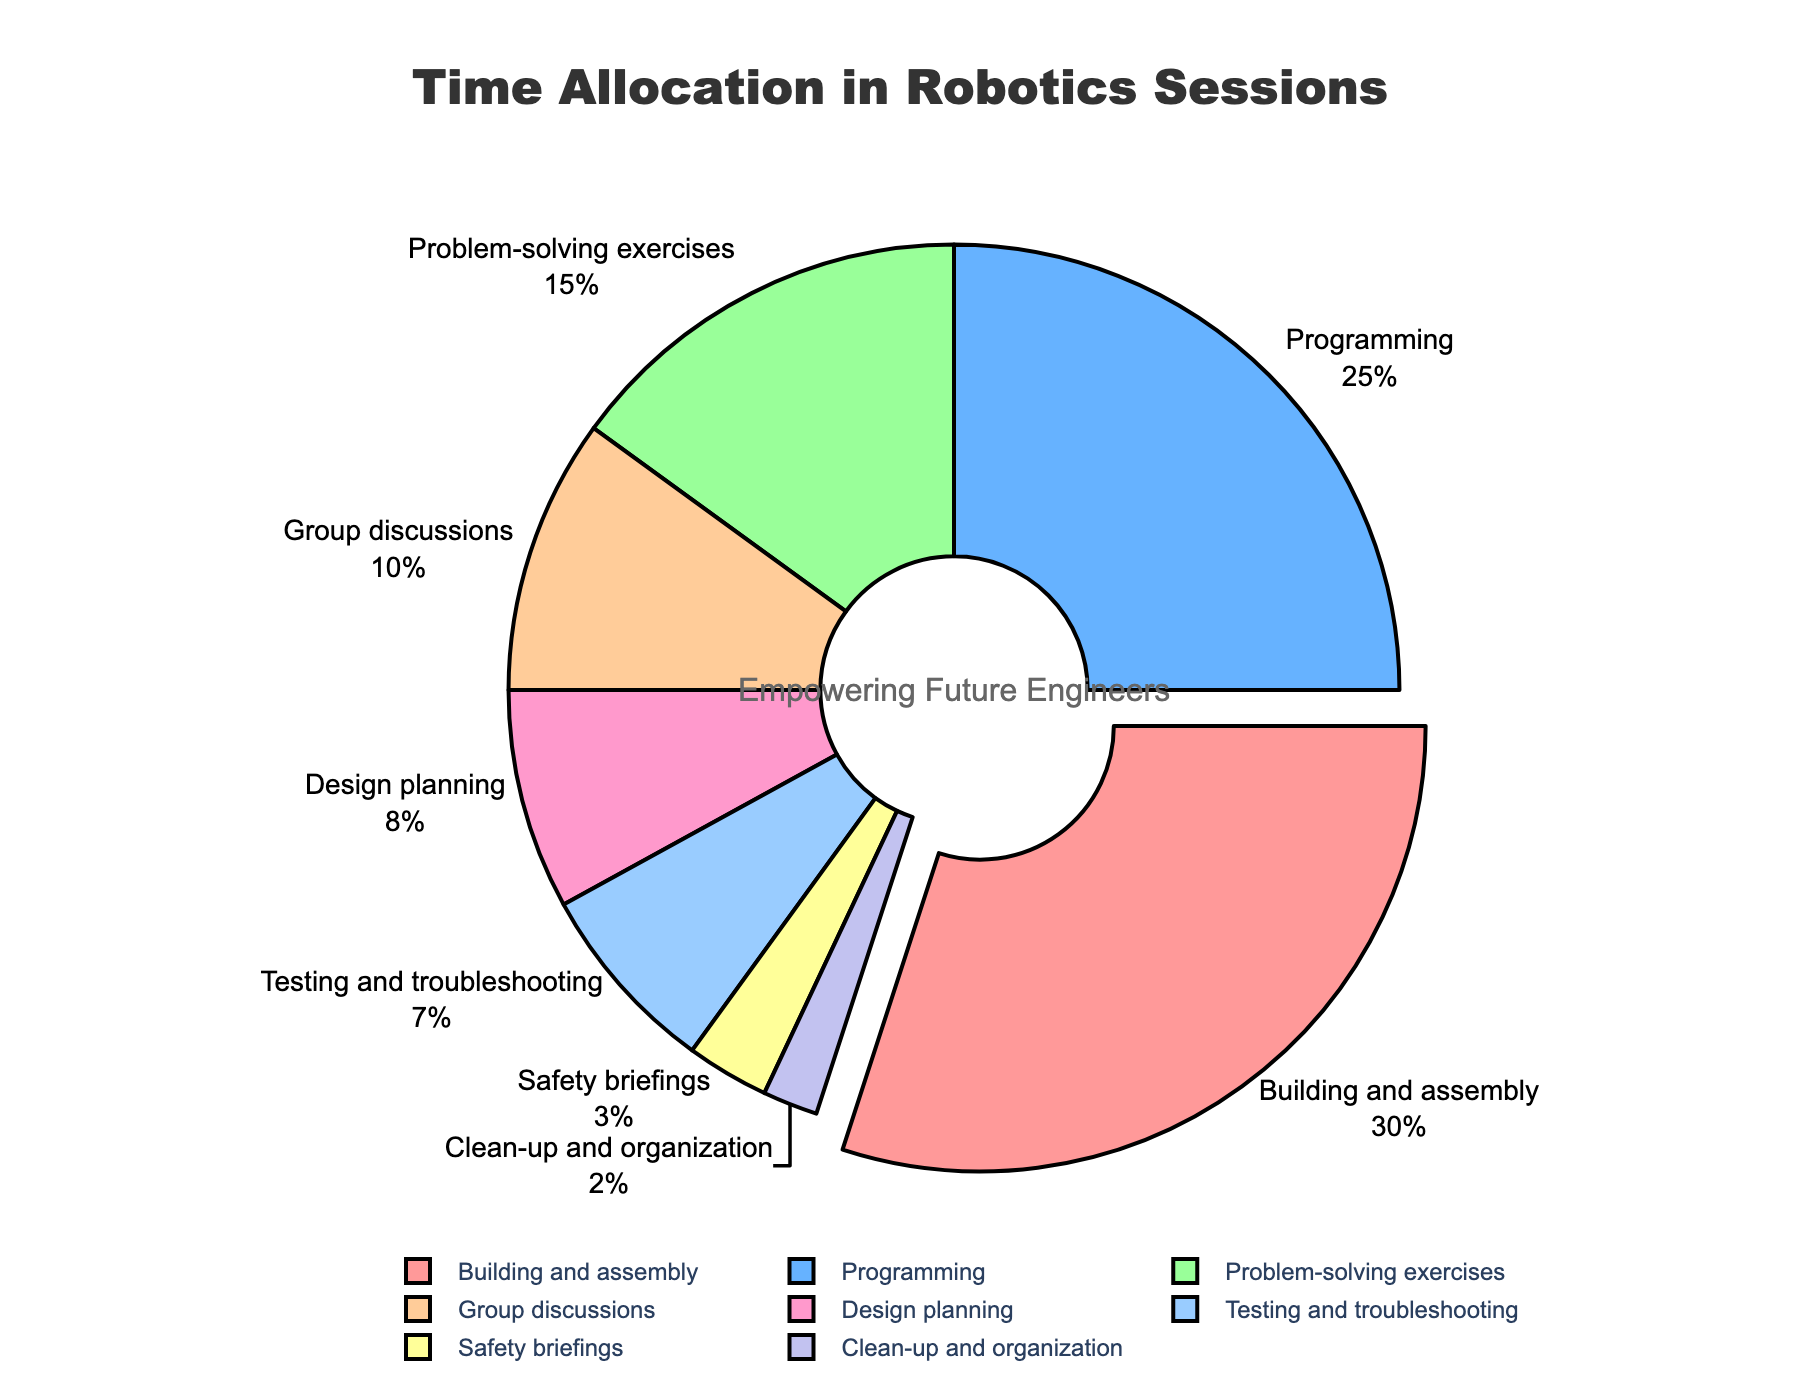What percentage of time is allocated to 'Programming'? The pie chart shows the allocation of time spent on different activities during robotics sessions. Looking at the labels on the chart, 'Programming' accounts for 25%.
Answer: 25% Which activity takes up most of the session time? By observing the size of the pie slices and the percentage labels, 'Building and assembly' has the largest slice with 30%.
Answer: Building and assembly How much more time is spent on 'Design planning' than 'Safety briefings'? The chart shows 'Design planning' at 8% and 'Safety briefings' at 3%. Subtracting the two percentages: 8% - 3% = 5%.
Answer: 5% Are 'Group discussions' and 'Problem-solving exercises' allocated the same amount of time? Looking at the pie chart, 'Group discussions' is allocated 10%, and 'Problem-solving exercises' is 15%. They are not equal as different percentages are assigned.
Answer: No If 'Building and assembly' and 'Programming' times are combined, what fraction of the session do they make up? Combining 'Building and assembly' at 30% and 'Programming' at 25%: 30% + 25% = 55%.
Answer: 55% Which activity has the smallest allocation, and what is its percentage? Observing the pie chart, the smallest slice is for 'Clean-up and organization' with 2%.
Answer: Clean-up and organization, 2% Is the time allocated to 'Testing and troubleshooting' greater than that for 'Design planning'? The chart shows 'Testing and troubleshooting' at 7% and 'Design planning' at 8%. 7% is less than 8%, so it is not greater.
Answer: No Add up the time spent on 'Problem-solving exercises', 'Group discussions', and 'Design planning'. What is the total percentage? Based on the chart, 'Problem-solving exercises' = 15%, 'Group discussions' = 10%, and 'Design planning' = 8%. Summing them up: 15% + 10% + 8% = 33%.
Answer: 33% Which segment is shown in red color and what is its percentage? The pie chart uses different colors for different activities, and the red segment represents 'Building and assembly' at 30%.
Answer: Building and assembly, 30% Is the percentage of time spent on 'Safety briefings' less than one-fourth of the time spent on 'Building and assembly'? 'Safety briefings' is at 3% and one-fourth of 'Building and assembly' (30%) is 30% / 4 = 7.5%. Since 3% is less than 7.5%, the statement is true.
Answer: Yes 